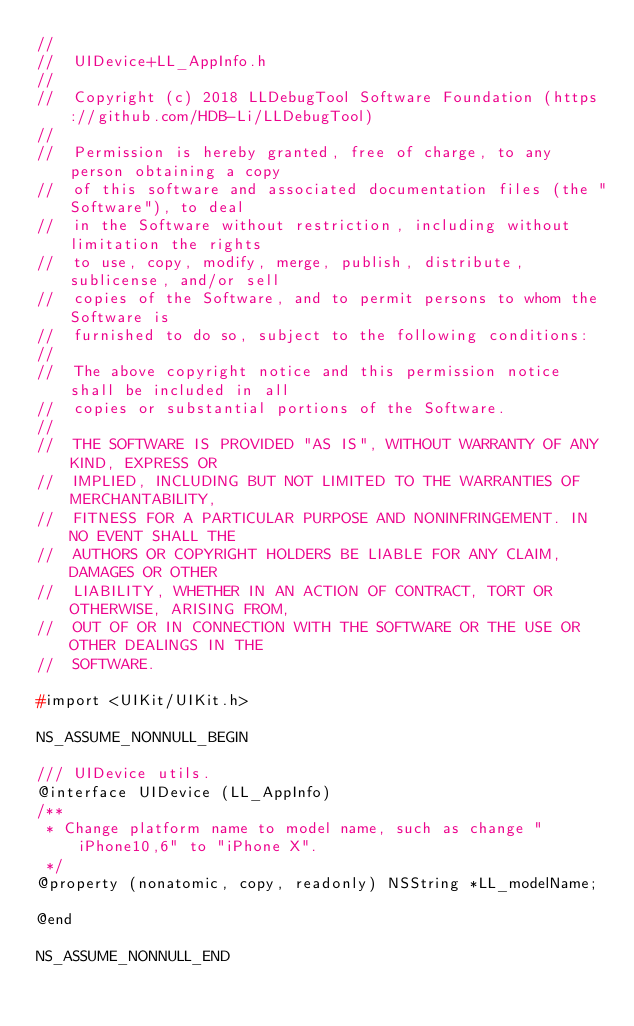Convert code to text. <code><loc_0><loc_0><loc_500><loc_500><_C_>//
//  UIDevice+LL_AppInfo.h
//
//  Copyright (c) 2018 LLDebugTool Software Foundation (https://github.com/HDB-Li/LLDebugTool)
//
//  Permission is hereby granted, free of charge, to any person obtaining a copy
//  of this software and associated documentation files (the "Software"), to deal
//  in the Software without restriction, including without limitation the rights
//  to use, copy, modify, merge, publish, distribute, sublicense, and/or sell
//  copies of the Software, and to permit persons to whom the Software is
//  furnished to do so, subject to the following conditions:
//
//  The above copyright notice and this permission notice shall be included in all
//  copies or substantial portions of the Software.
//
//  THE SOFTWARE IS PROVIDED "AS IS", WITHOUT WARRANTY OF ANY KIND, EXPRESS OR
//  IMPLIED, INCLUDING BUT NOT LIMITED TO THE WARRANTIES OF MERCHANTABILITY,
//  FITNESS FOR A PARTICULAR PURPOSE AND NONINFRINGEMENT. IN NO EVENT SHALL THE
//  AUTHORS OR COPYRIGHT HOLDERS BE LIABLE FOR ANY CLAIM, DAMAGES OR OTHER
//  LIABILITY, WHETHER IN AN ACTION OF CONTRACT, TORT OR OTHERWISE, ARISING FROM,
//  OUT OF OR IN CONNECTION WITH THE SOFTWARE OR THE USE OR OTHER DEALINGS IN THE
//  SOFTWARE.

#import <UIKit/UIKit.h>

NS_ASSUME_NONNULL_BEGIN

/// UIDevice utils.
@interface UIDevice (LL_AppInfo)
/**
 * Change platform name to model name, such as change "iPhone10,6" to "iPhone X".
 */
@property (nonatomic, copy, readonly) NSString *LL_modelName;

@end

NS_ASSUME_NONNULL_END
</code> 